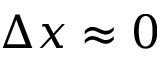<formula> <loc_0><loc_0><loc_500><loc_500>\Delta x \approx 0</formula> 